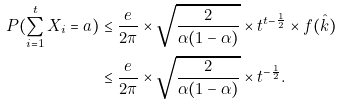Convert formula to latex. <formula><loc_0><loc_0><loc_500><loc_500>P ( \sum _ { i = 1 } ^ { t } X _ { i } = a ) & \leq \frac { e } { 2 \pi } \times \sqrt { \frac { 2 } { \alpha ( 1 - \alpha ) } } \times t ^ { t - \frac { 1 } { 2 } } \times f ( \hat { k } ) \\ & \leq \frac { e } { 2 \pi } \times \sqrt { \frac { 2 } { \alpha ( 1 - \alpha ) } } \times t ^ { - \frac { 1 } { 2 } } .</formula> 